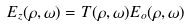<formula> <loc_0><loc_0><loc_500><loc_500>E _ { z } ( \rho , \omega ) = T ( \rho , \omega ) E _ { o } ( \rho , \omega )</formula> 